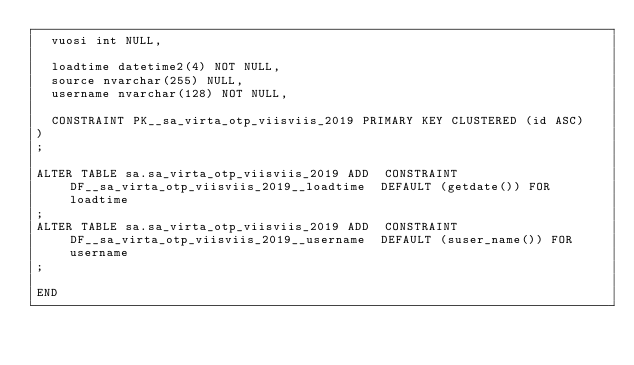Convert code to text. <code><loc_0><loc_0><loc_500><loc_500><_SQL_>  vuosi int NULL,

  loadtime datetime2(4) NOT NULL,
  source nvarchar(255) NULL,
  username nvarchar(128) NOT NULL,
  
  CONSTRAINT PK__sa_virta_otp_viisviis_2019 PRIMARY KEY CLUSTERED (id ASC)
)
;

ALTER TABLE sa.sa_virta_otp_viisviis_2019 ADD  CONSTRAINT DF__sa_virta_otp_viisviis_2019__loadtime  DEFAULT (getdate()) FOR loadtime
;
ALTER TABLE sa.sa_virta_otp_viisviis_2019 ADD  CONSTRAINT DF__sa_virta_otp_viisviis_2019__username  DEFAULT (suser_name()) FOR username
;

END
</code> 